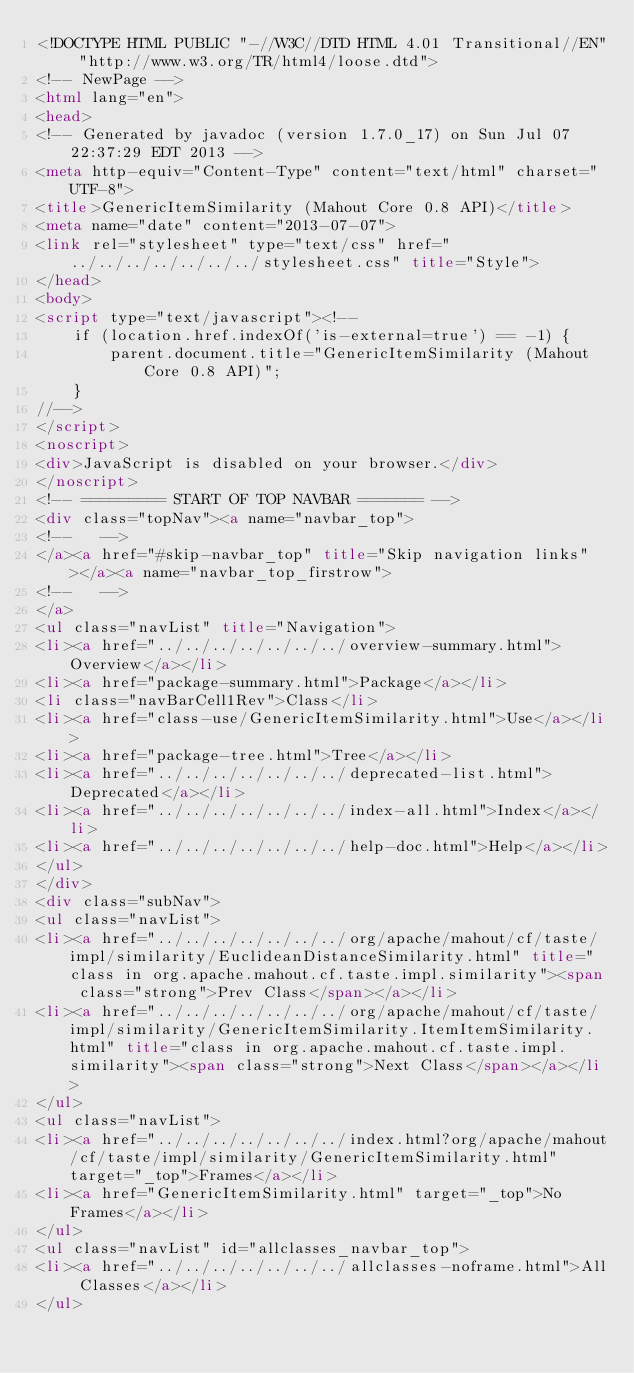<code> <loc_0><loc_0><loc_500><loc_500><_HTML_><!DOCTYPE HTML PUBLIC "-//W3C//DTD HTML 4.01 Transitional//EN" "http://www.w3.org/TR/html4/loose.dtd">
<!-- NewPage -->
<html lang="en">
<head>
<!-- Generated by javadoc (version 1.7.0_17) on Sun Jul 07 22:37:29 EDT 2013 -->
<meta http-equiv="Content-Type" content="text/html" charset="UTF-8">
<title>GenericItemSimilarity (Mahout Core 0.8 API)</title>
<meta name="date" content="2013-07-07">
<link rel="stylesheet" type="text/css" href="../../../../../../../stylesheet.css" title="Style">
</head>
<body>
<script type="text/javascript"><!--
    if (location.href.indexOf('is-external=true') == -1) {
        parent.document.title="GenericItemSimilarity (Mahout Core 0.8 API)";
    }
//-->
</script>
<noscript>
<div>JavaScript is disabled on your browser.</div>
</noscript>
<!-- ========= START OF TOP NAVBAR ======= -->
<div class="topNav"><a name="navbar_top">
<!--   -->
</a><a href="#skip-navbar_top" title="Skip navigation links"></a><a name="navbar_top_firstrow">
<!--   -->
</a>
<ul class="navList" title="Navigation">
<li><a href="../../../../../../../overview-summary.html">Overview</a></li>
<li><a href="package-summary.html">Package</a></li>
<li class="navBarCell1Rev">Class</li>
<li><a href="class-use/GenericItemSimilarity.html">Use</a></li>
<li><a href="package-tree.html">Tree</a></li>
<li><a href="../../../../../../../deprecated-list.html">Deprecated</a></li>
<li><a href="../../../../../../../index-all.html">Index</a></li>
<li><a href="../../../../../../../help-doc.html">Help</a></li>
</ul>
</div>
<div class="subNav">
<ul class="navList">
<li><a href="../../../../../../../org/apache/mahout/cf/taste/impl/similarity/EuclideanDistanceSimilarity.html" title="class in org.apache.mahout.cf.taste.impl.similarity"><span class="strong">Prev Class</span></a></li>
<li><a href="../../../../../../../org/apache/mahout/cf/taste/impl/similarity/GenericItemSimilarity.ItemItemSimilarity.html" title="class in org.apache.mahout.cf.taste.impl.similarity"><span class="strong">Next Class</span></a></li>
</ul>
<ul class="navList">
<li><a href="../../../../../../../index.html?org/apache/mahout/cf/taste/impl/similarity/GenericItemSimilarity.html" target="_top">Frames</a></li>
<li><a href="GenericItemSimilarity.html" target="_top">No Frames</a></li>
</ul>
<ul class="navList" id="allclasses_navbar_top">
<li><a href="../../../../../../../allclasses-noframe.html">All Classes</a></li>
</ul></code> 